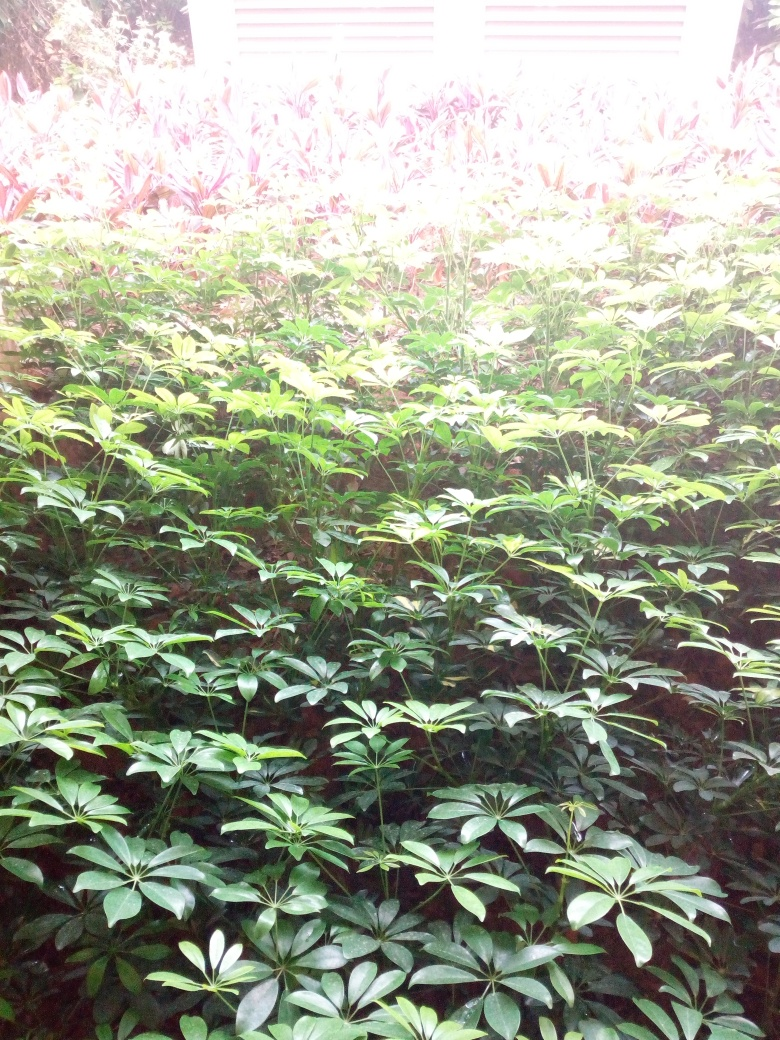Can you tell what time of day it might be in this image? Judging by the brightness and the white balance of the photo, it seems to be taken during daylight, possibly around midday when the sun is high. The light appears to be quite intense, indicating a time close to solar noon, although the exact time cannot be verified without shadows to give more specific clues. 